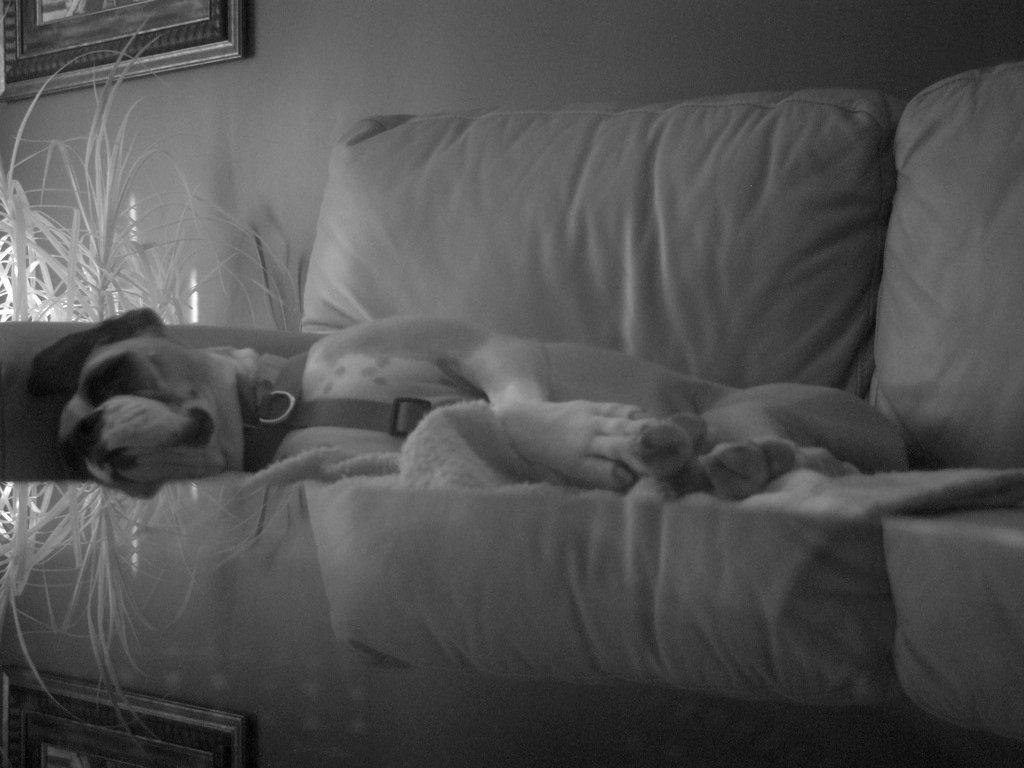What is the color scheme of the image? The image is in black and white. What piece of furniture is present in the image? There is a couch in the image. What is the dog doing in the image? The dog is lying on the couch. What type of plant is in the image? There is an artificial plant in the image. What can be seen on the wall in the image? The wall is visible in the image, and there is a photo frame attached to it. What type of organization is responsible for the profit displayed in the image? There is no mention of any organization or profit in the image; it features a couch, a dog, an artificial plant, and a photo frame on the wall. 